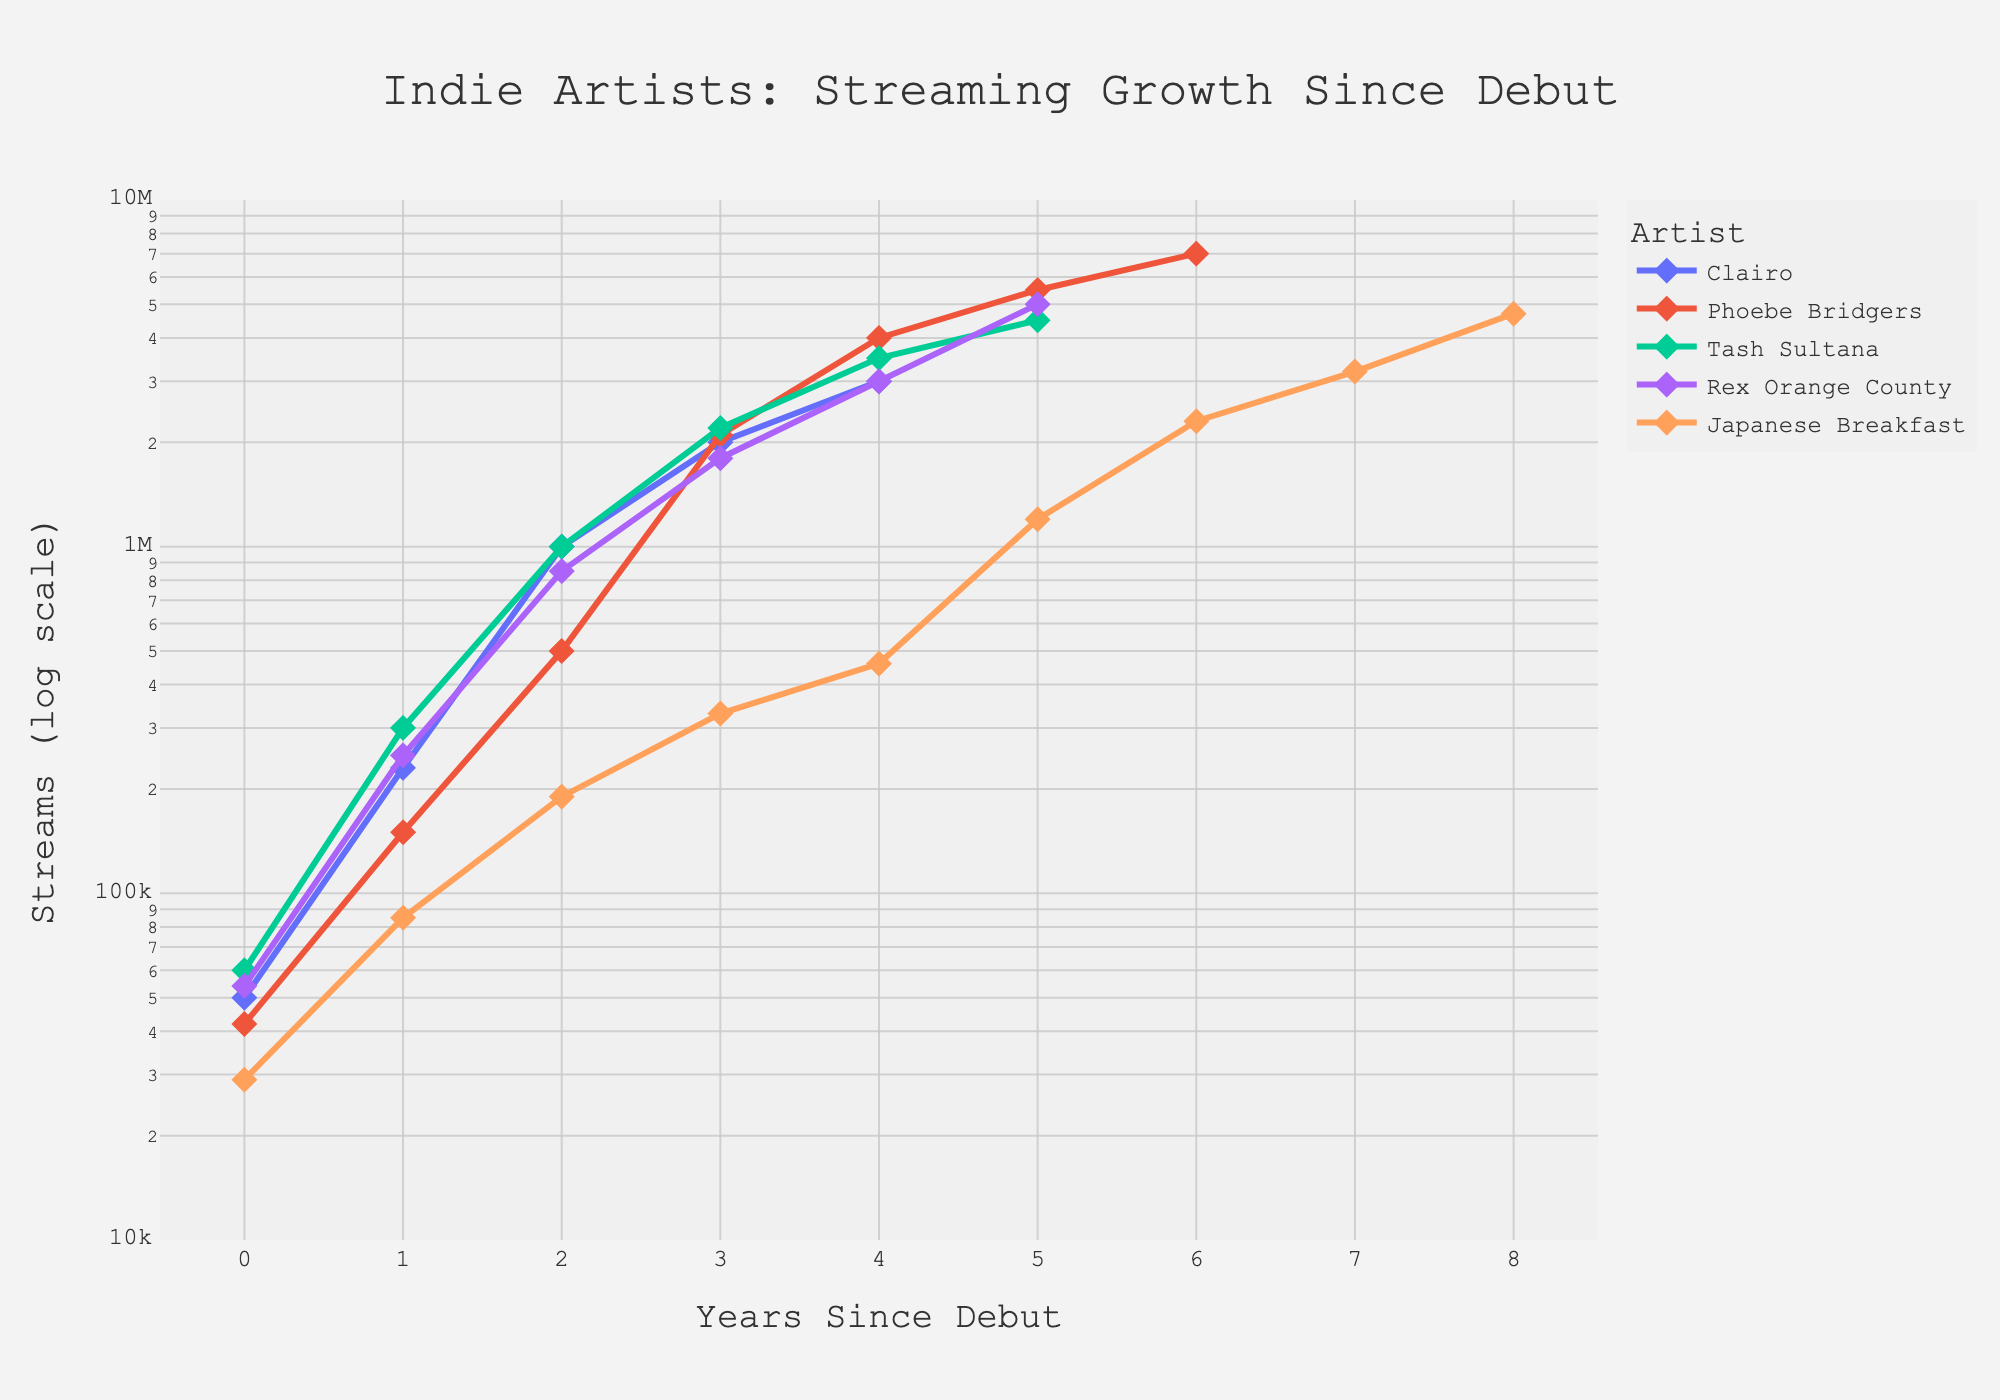What is the title of the figure? The title is usually at the top of the figure, centered, and can be recognized by its larger font size. For this figure, the title is clearly stated.
Answer: Indie Artists: Streaming Growth Since Debut What is the x-axis label? The x-axis label indicates the variable plotted along the horizontal direction of the plot. It's usually below the x-axis and is typically descriptive of the data. For this figure, we can check at the bottom of the x-axis.
Answer: Years Since Debut What is the y-axis label? The y-axis label indicates the variable plotted along the vertical direction of the plot. It's usually along the side of the y-axis and descriptive of the data. For this figure, it is visible on the left side.
Answer: Streams (log scale) How many artists are represented in the plot? Each artist is represented by a different color in the plot. By counting the distinct colors and corresponding legend items, we can determine the number of artists.
Answer: 5 Which artist had the highest number of streams in 2021? By finding the data points for the year 2021 and comparing their y-values, the artist with the highest y-value (streams) can be identified. The legend helps match the color to the artist.
Answer: Phoebe Bridgers How many years since Clairo's debut until her streams reached 1,000,000? By locating Clairo's data points and finding the point where the y-axis value is 1,000,000, we can trace this back to the corresponding x-axis value (Years Since Debut).
Answer: 2 years Which artist had the fastest growth in streams from the debut year to the peak year? (Consider overall trend) Examine the slopes of the lines for each artist from debut to their highest point on the plot. The steepest line indicates the fastest growth.
Answer: Phoebe Bridgers What is the difference in number of streams between Japanese Breakfast and Rex Orange County in their third year since debut? Find the third data point since debut for both artists and subtract the lower y-value from the higher y-value.
Answer: 240,000 streams What is the average streams for Tash Sultana in the first four years since debut? Sum the y-values (streams) for Tash Sultana in the first four years since debut and divide by 4. Sum of streams: 60,000 + 300,000 + 1,000,000 + 2,200,000 = 3,560,000. Average is 3,560,000 / 4.
Answer: 890,000 streams Which artist had more streams in 2018, Clairo or Japanese Breakfast? Locate the data points for Clairo and Japanese Breakfast in the year 2018 and compare their y-values (streams).
Answer: Clairo 